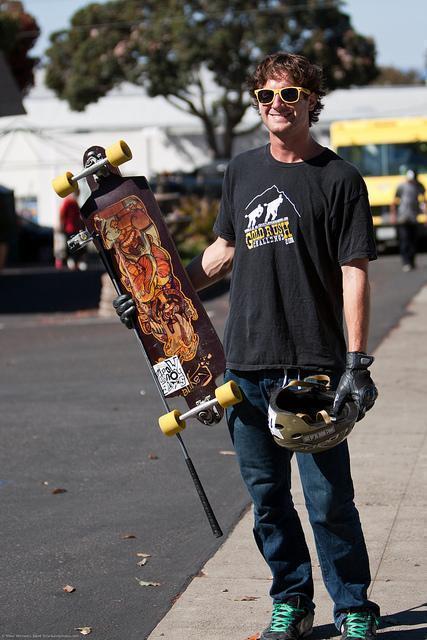What type of board does the man have?
Select the accurate response from the four choices given to answer the question.
Options: Skate board, land board, body board, long board. Long board. 